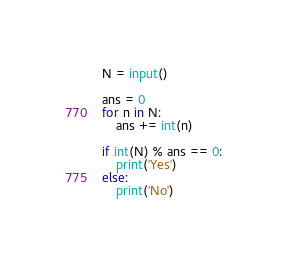Convert code to text. <code><loc_0><loc_0><loc_500><loc_500><_Python_>N = input()

ans = 0
for n in N:
    ans += int(n)

if int(N) % ans == 0:
    print('Yes')
else:
    print('No')</code> 